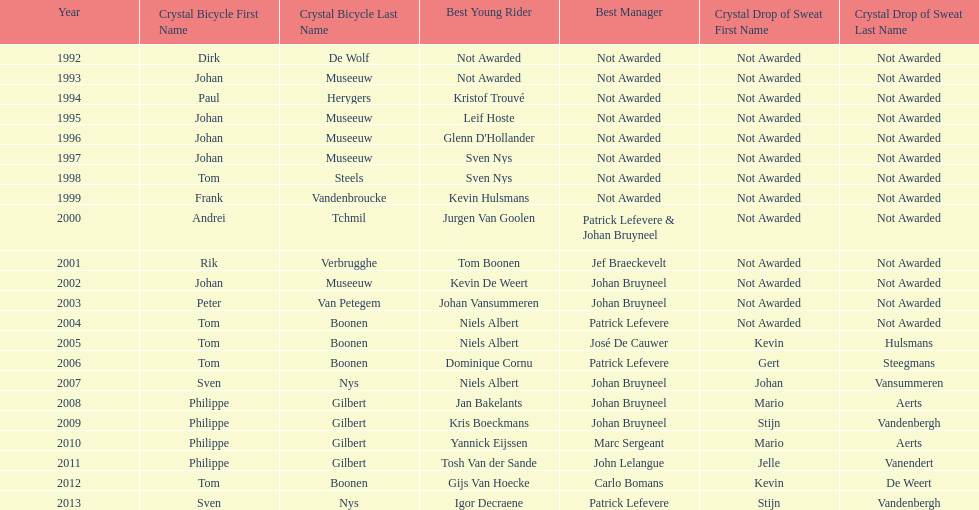Who won the most consecutive crystal bicycles? Philippe Gilbert. 